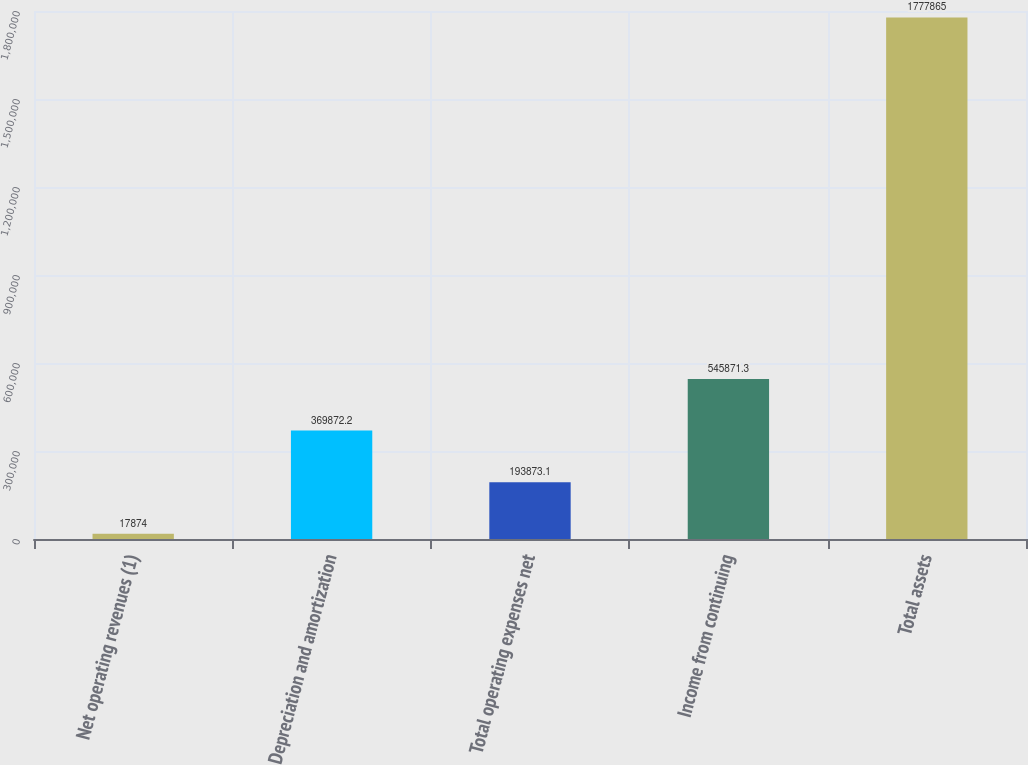Convert chart. <chart><loc_0><loc_0><loc_500><loc_500><bar_chart><fcel>Net operating revenues (1)<fcel>Depreciation and amortization<fcel>Total operating expenses net<fcel>Income from continuing<fcel>Total assets<nl><fcel>17874<fcel>369872<fcel>193873<fcel>545871<fcel>1.77786e+06<nl></chart> 